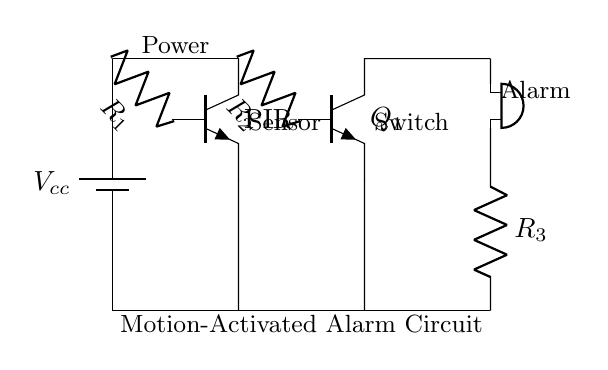What is the main function of the PIR sensor in this circuit? The PIR sensor detects motion, which activates the alarm when it senses movement nearby.
Answer: motion detection What is used to amplify the signal from the PIR sensor? The transistor Q1 amplifies the current and voltage from the PIR sensor to drive the alarm circuit.
Answer: transistor What is the value of R1 in the circuit? The resistance value of R1 is not explicitly stated, but it is connected to the PIR sensor, likely to limit the current.
Answer: unspecified Which component is responsible for sounding the alarm? The buzzer is the component that produces sound to alert against theft when activated.
Answer: buzzer What type of circuit is this? This is a low power alarm circuit designed to deter theft.
Answer: alarm circuit How does the motion-activated system get powered? The circuit is powered by a battery, denoted as Vcc, which supplies the necessary voltage to all components.
Answer: battery 